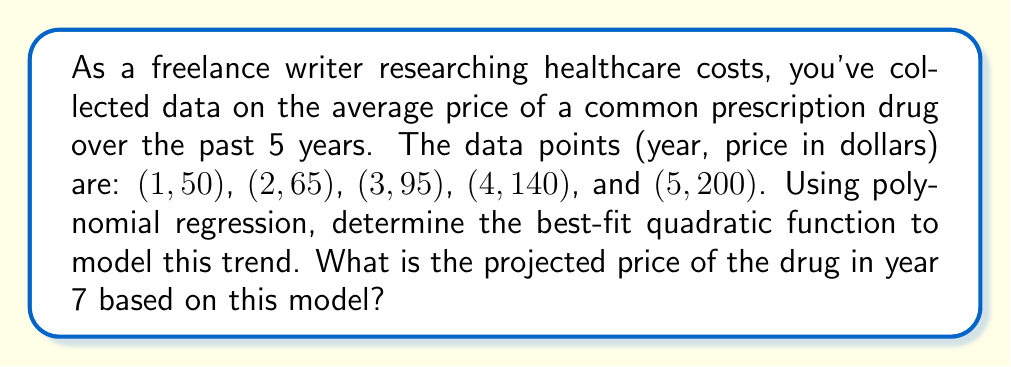Solve this math problem. 1. We need to find a quadratic function in the form $f(x) = ax^2 + bx + c$ that best fits the given data points.

2. To find the coefficients $a$, $b$, and $c$, we'll use the least squares method. This involves solving the following system of equations:

   $$\begin{cases}
   \sum y = an\sum x^2 + b\sum x + cn \\
   \sum xy = a\sum x^3 + b\sum x^2 + c\sum x \\
   \sum x^2y = a\sum x^4 + b\sum x^3 + c\sum x^2
   \end{cases}$$

3. Calculate the necessary sums:
   $n = 5$
   $\sum x = 1 + 2 + 3 + 4 + 5 = 15$
   $\sum x^2 = 1 + 4 + 9 + 16 + 25 = 55$
   $\sum x^3 = 1 + 8 + 27 + 64 + 125 = 225$
   $\sum x^4 = 1 + 16 + 81 + 256 + 625 = 979$
   $\sum y = 50 + 65 + 95 + 140 + 200 = 550$
   $\sum xy = 50 + 130 + 285 + 560 + 1000 = 2025$
   $\sum x^2y = 50 + 260 + 855 + 2240 + 5000 = 8405$

4. Substitute these values into the system of equations:

   $$\begin{cases}
   550 = 55a + 15b + 5c \\
   2025 = 225a + 55b + 15c \\
   8405 = 979a + 225b + 55c
   \end{cases}$$

5. Solve this system of equations (using a calculator or computer algebra system) to get:
   $a = 5$, $b = -5$, $c = 50$

6. The best-fit quadratic function is therefore:
   $f(x) = 5x^2 - 5x + 50$

7. To project the price in year 7, substitute $x = 7$ into this function:
   $f(7) = 5(7)^2 - 5(7) + 50 = 5(49) - 35 + 50 = 260$
Answer: $260 